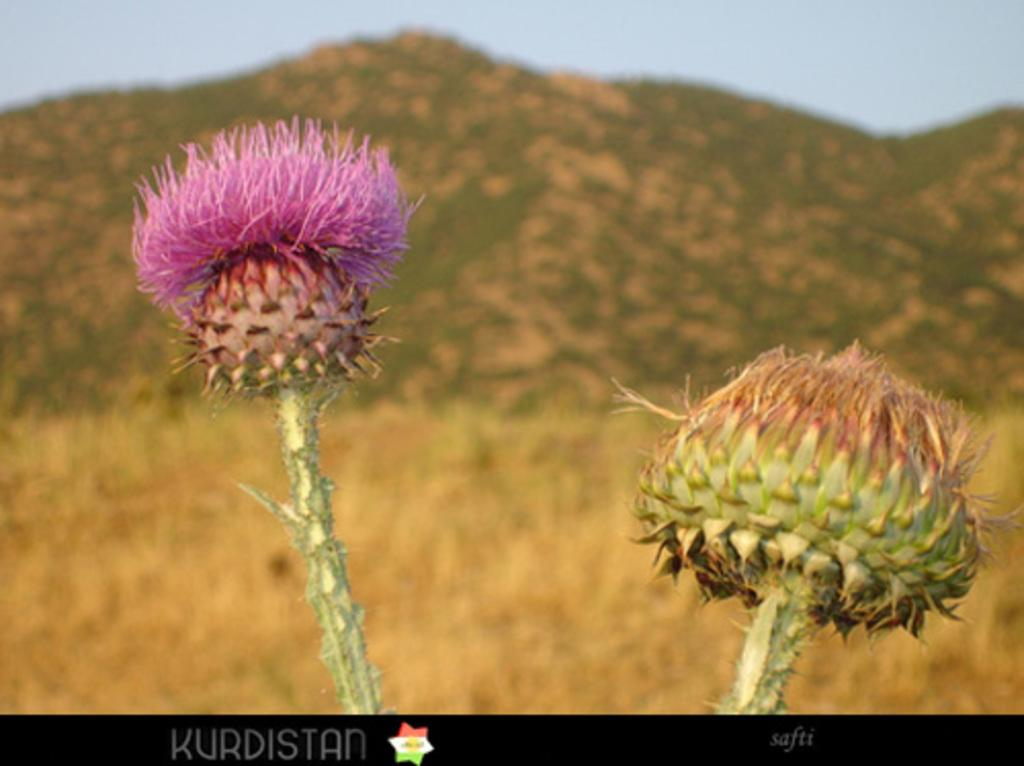What type of plants can be seen in the image? There are flowers in the image. What can be seen in the background of the image? There is grass, a hill, and the sky visible in the background of the image. What is written or displayed at the bottom of the image? There are texts and a logo at the bottom of the image. Can you describe the argument between the flowers in the image? There is no argument between the flowers in the image, as flowers do not engage in arguments. 